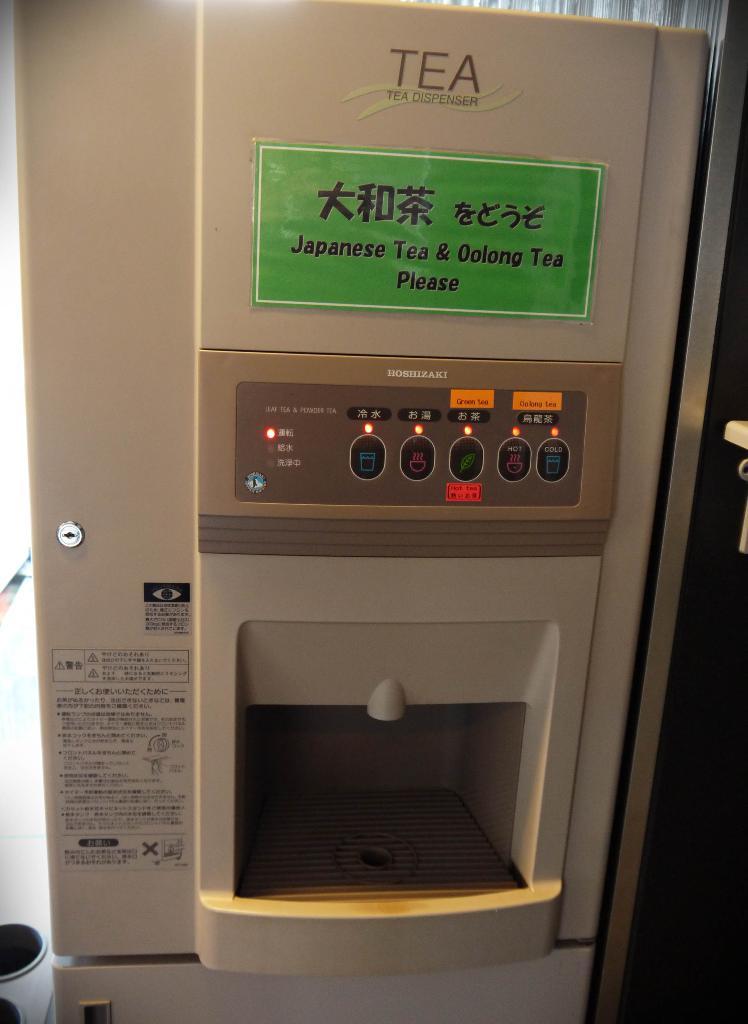What sort of machine is this?
Provide a succinct answer. Tea. What drink is coming from the machine?
Provide a short and direct response. Tea. 